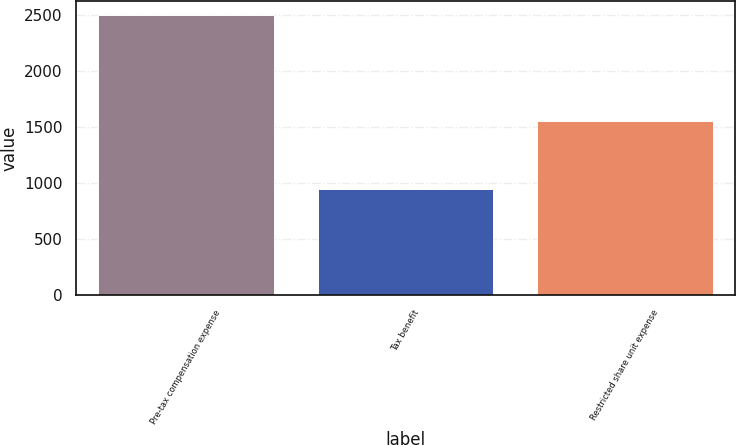Convert chart. <chart><loc_0><loc_0><loc_500><loc_500><bar_chart><fcel>Pre-tax compensation expense<fcel>Tax benefit<fcel>Restricted share unit expense<nl><fcel>2496<fcel>946<fcel>1550<nl></chart> 